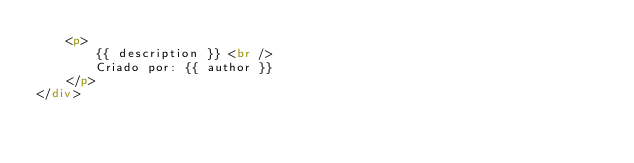<code> <loc_0><loc_0><loc_500><loc_500><_HTML_>	<p>
		{{ description }} <br />		
		Criado por: {{ author }}
	</p>
</div>
</code> 